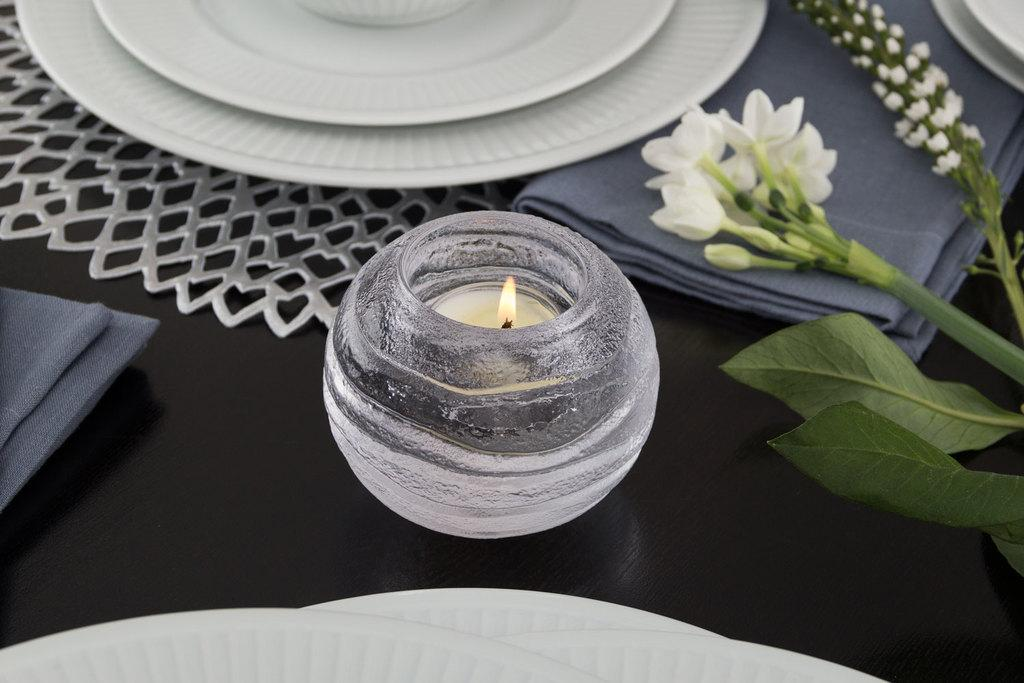What is the main object in the image? There is a candle in the image. What other objects can be seen in the image? There are flowers with stems and plates visible in the image. What is covering the table in the image? There is cloth placed on the table in the image. Where is the mitten located in the image? There is no mitten present in the image. What type of land can be seen in the image? The image does not depict any land; it features a candle, flowers with stems, plates, and a cloth-covered table. 